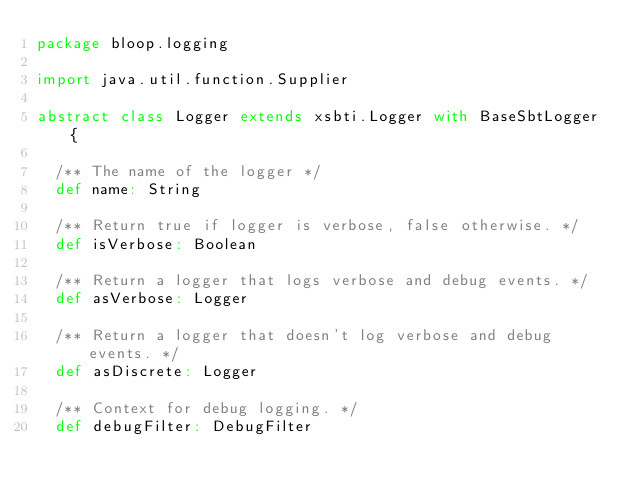Convert code to text. <code><loc_0><loc_0><loc_500><loc_500><_Scala_>package bloop.logging

import java.util.function.Supplier

abstract class Logger extends xsbti.Logger with BaseSbtLogger {

  /** The name of the logger */
  def name: String

  /** Return true if logger is verbose, false otherwise. */
  def isVerbose: Boolean

  /** Return a logger that logs verbose and debug events. */
  def asVerbose: Logger

  /** Return a logger that doesn't log verbose and debug events. */
  def asDiscrete: Logger

  /** Context for debug logging. */
  def debugFilter: DebugFilter
</code> 